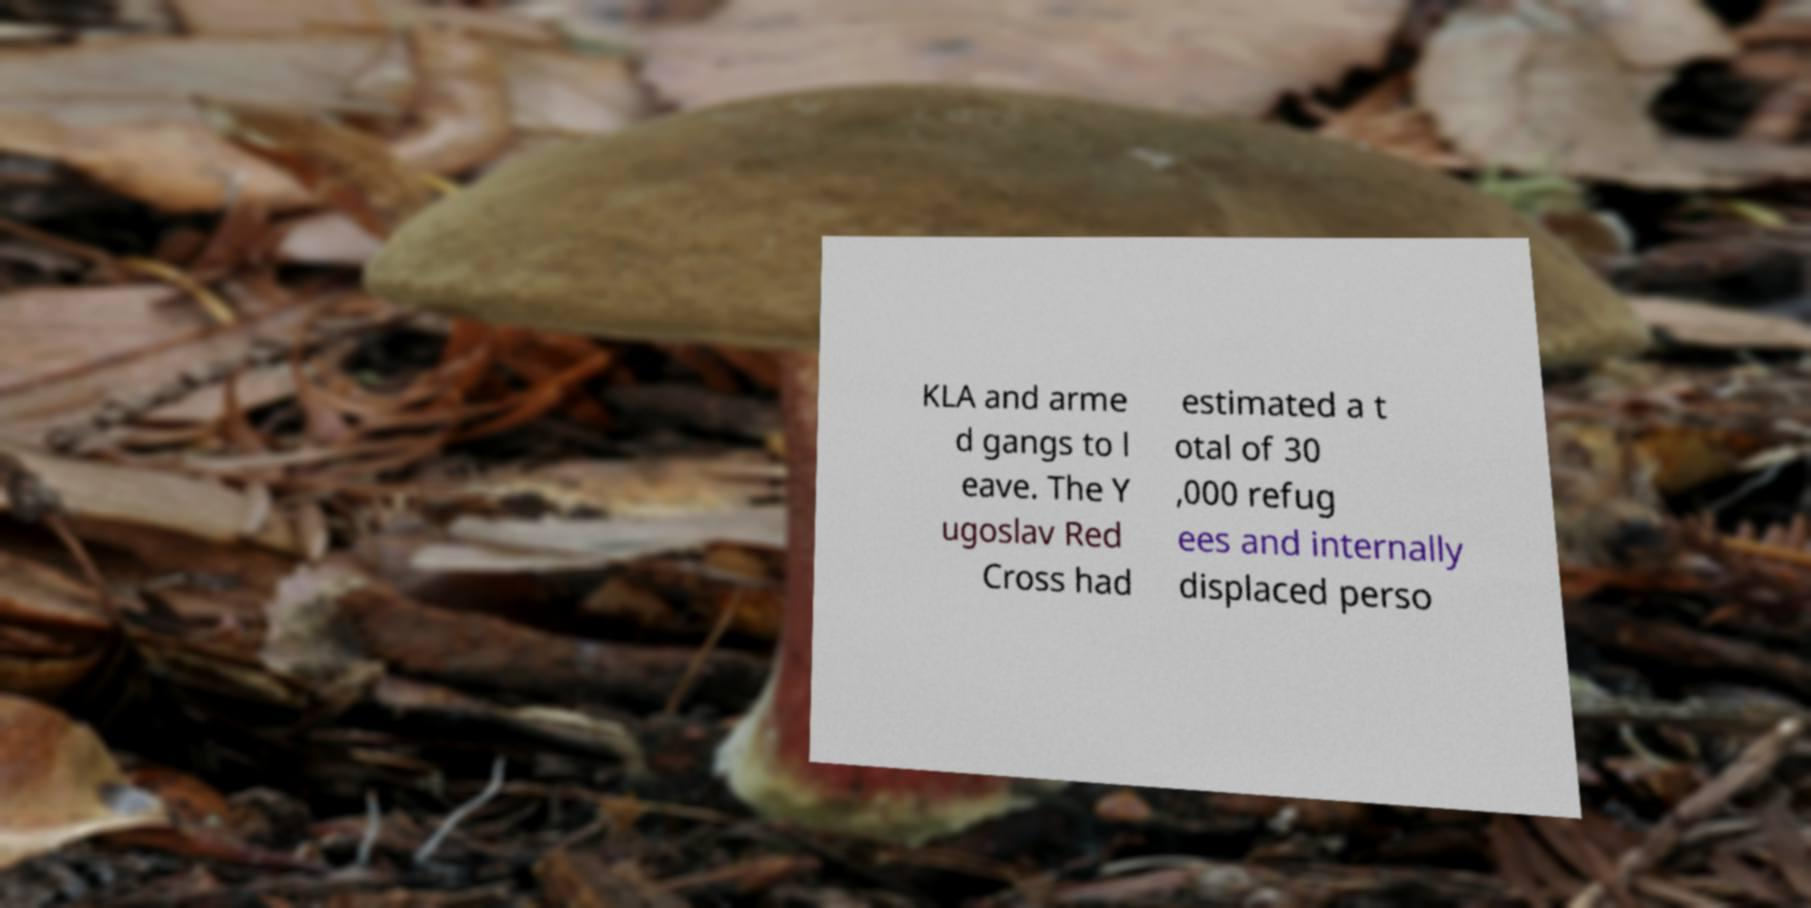I need the written content from this picture converted into text. Can you do that? KLA and arme d gangs to l eave. The Y ugoslav Red Cross had estimated a t otal of 30 ,000 refug ees and internally displaced perso 